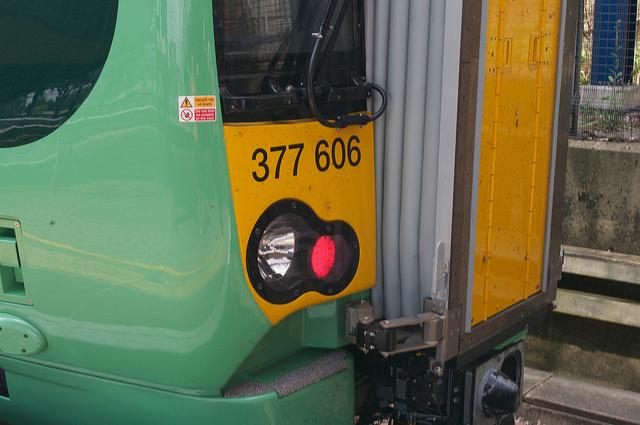What are the numbers on the train?
Give a very brief answer. 377 606. Is this a vehicle?
Answer briefly. Yes. What colors are the train?
Give a very brief answer. Green and yellow. 